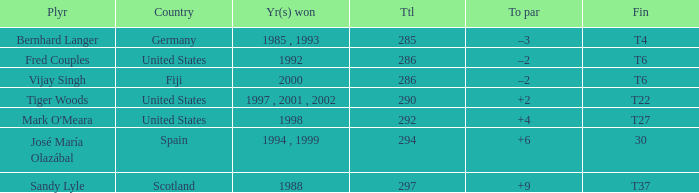What is the total for Bernhard Langer? 1.0. Would you be able to parse every entry in this table? {'header': ['Plyr', 'Country', 'Yr(s) won', 'Ttl', 'To par', 'Fin'], 'rows': [['Bernhard Langer', 'Germany', '1985 , 1993', '285', '–3', 'T4'], ['Fred Couples', 'United States', '1992', '286', '–2', 'T6'], ['Vijay Singh', 'Fiji', '2000', '286', '–2', 'T6'], ['Tiger Woods', 'United States', '1997 , 2001 , 2002', '290', '+2', 'T22'], ["Mark O'Meara", 'United States', '1998', '292', '+4', 'T27'], ['José María Olazábal', 'Spain', '1994 , 1999', '294', '+6', '30'], ['Sandy Lyle', 'Scotland', '1988', '297', '+9', 'T37']]} 